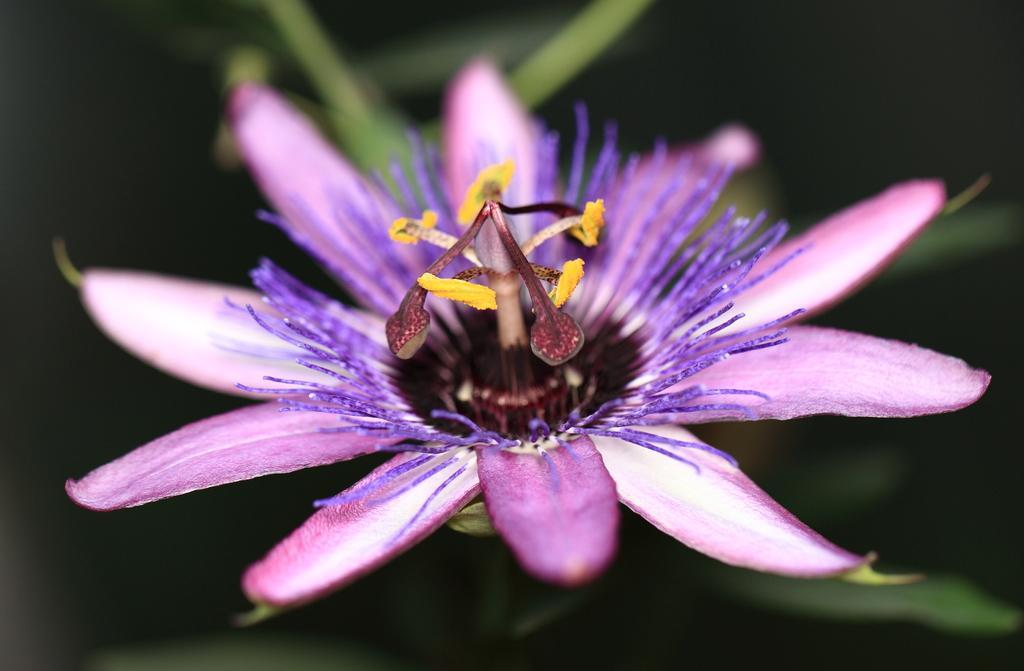Can you describe this image briefly? In this image, we can see a flower. In the background, there is a blur view. 